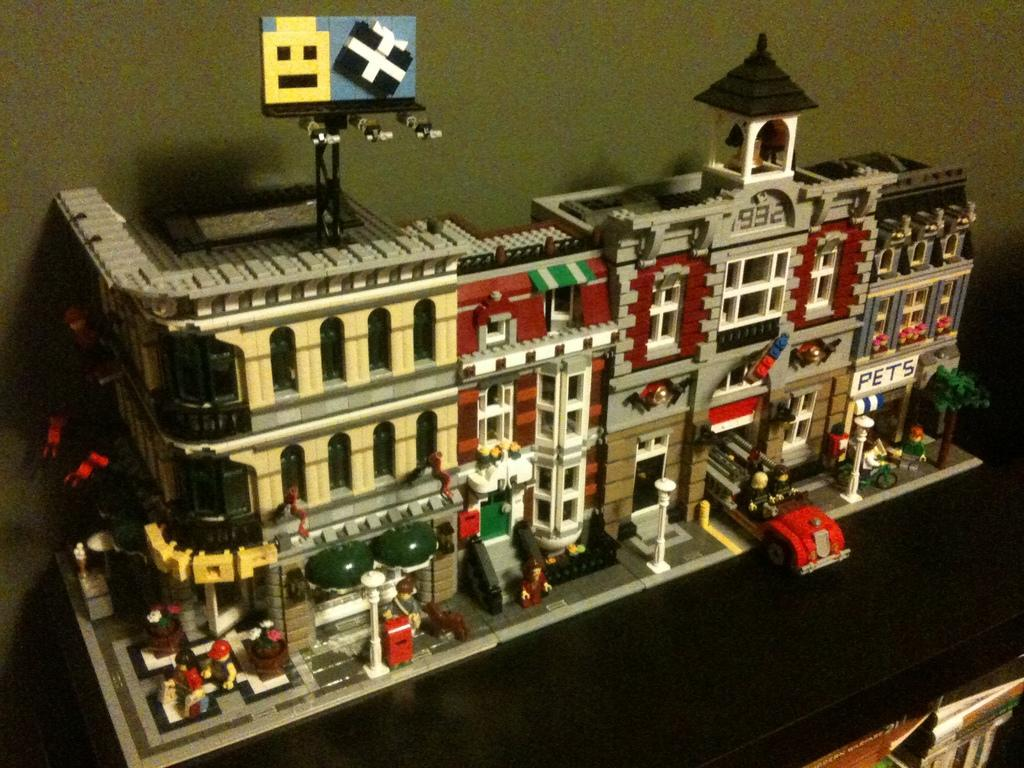What is the main subject of the image? There is a model of a building in the image. On what surface is the model placed? The model is placed on a black surface. What else can be seen in the image? There are books in the right bottom of the image. What is visible in the background of the image? There is a wall in the background of the image. Can you hear the wave crashing in the image? There is no wave present in the image, so it is not possible to hear any crashing sounds. 